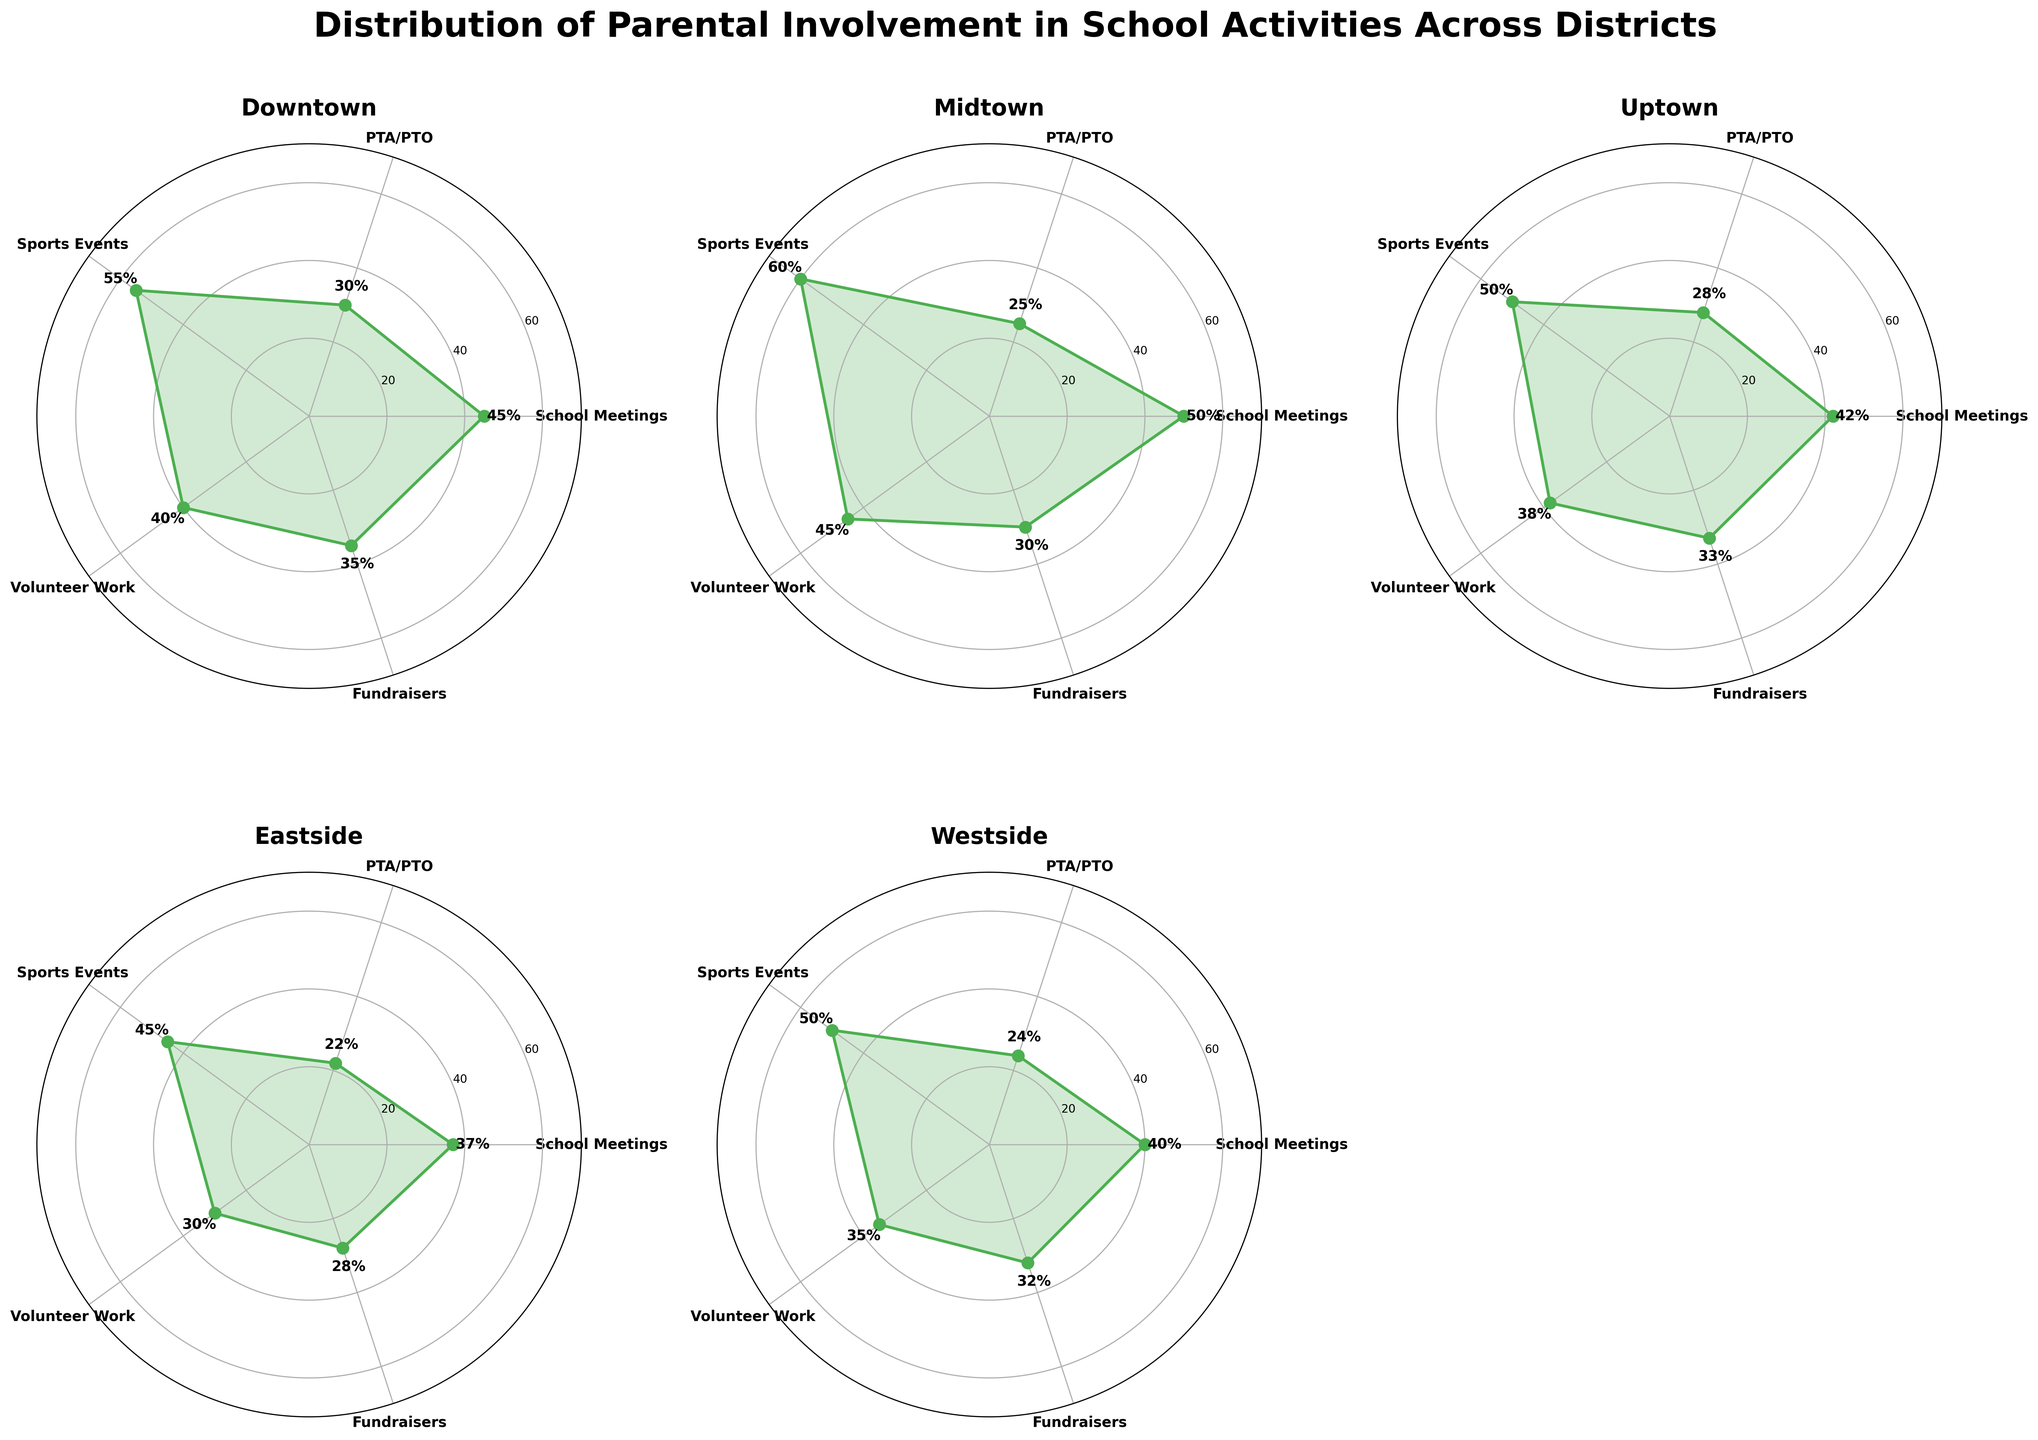Which district has the highest parental involvement in sports events? Look at the plot for each district and identify the point for "Sports Events." Compare the values and find the highest one. Midtown has 60% which is the highest.
Answer: Midtown What is the average parental involvement percentage in fundraisers across all districts? For each district, find the percentage involvement in "Fundraisers" and calculate the average. Downtown has 35%, Midtown has 30%, Uptown has 33%, Eastside has 28%, and Westside has 32%. The average is (35 + 30 + 33 + 28 + 32) / 5 = 31.6%.
Answer: 31.6% Which activity shows the least amount of parental involvement in Eastside? Look at the plot for Eastside and identify the activity with the smallest value. "PTA/PTO" has the lowest value at 22%.
Answer: PTA/PTO Compare the parental involvement in school meetings between Downtown and Uptown. Which district has more involvement? Compare the "School Meetings" values for Downtown and Uptown from their respective rose charts. Downtown has 45% and Uptown has 42%, so Downtown has more involvement.
Answer: Downtown What is the range of parental involvement percentages for volunteer work across all districts? Identify the minimum and maximum percentages for "Volunteer Work" across all districts. Eastside has the lowest at 30% and Midtown has the highest at 45%. The range is 45 - 30 = 15%.
Answer: 15% Which district has the most evenly distributed parental involvement across all activities? Look for the district where the values for all activities are most consistent (less variable). Compare the range of values from highest to lowest across activities within each district. Westside has values ranging from 24% to 50%, which is more consistent compared to other districts.
Answer: Westside Is parental involvement in PTA/PTO generally higher or lower than involvement in sports events? Compare the values for "PTA/PTO" and "Sports Events" across all districts. Sports events generally have higher values than PTA/PTO involvement.
Answer: Lower In which activity does Westside have the highest parental involvement percentage? Identify the highest percentage for Westside. The highest is "Sports Events" with 50%.
Answer: Sports Events If we sum the parental involvement percentages in school meetings from all districts, what is the result? Add the "School Meetings" percentages together from each district: Downtown (45%), Midtown (50%), Uptown (42%), Eastside (37%), Westside (40%). The sum is 45 + 50 + 42 + 37 + 40 = 214%.
Answer: 214% 